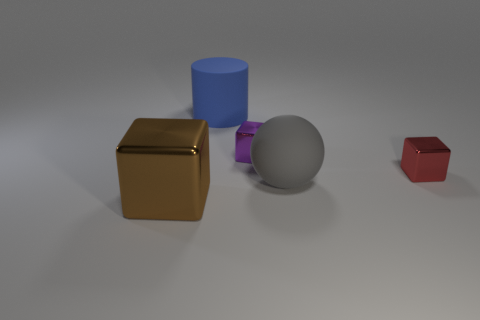What is the shape of the blue thing that is the same material as the big sphere?
Provide a short and direct response. Cylinder. Is there anything else that has the same color as the cylinder?
Your answer should be compact. No. The tiny metallic block to the left of the red block is what color?
Provide a succinct answer. Purple. Is the color of the tiny cube that is to the left of the matte sphere the same as the big ball?
Ensure brevity in your answer.  No. There is another small object that is the same shape as the tiny red object; what is it made of?
Your answer should be very brief. Metal. How many purple blocks are the same size as the brown metal cube?
Give a very brief answer. 0. What is the shape of the gray object?
Your answer should be very brief. Sphere. There is a thing that is both in front of the small red metallic block and to the right of the big brown cube; what size is it?
Provide a short and direct response. Large. There is a block on the left side of the large rubber cylinder; what material is it?
Your response must be concise. Metal. There is a sphere; is it the same color as the metallic thing right of the purple block?
Offer a terse response. No. 